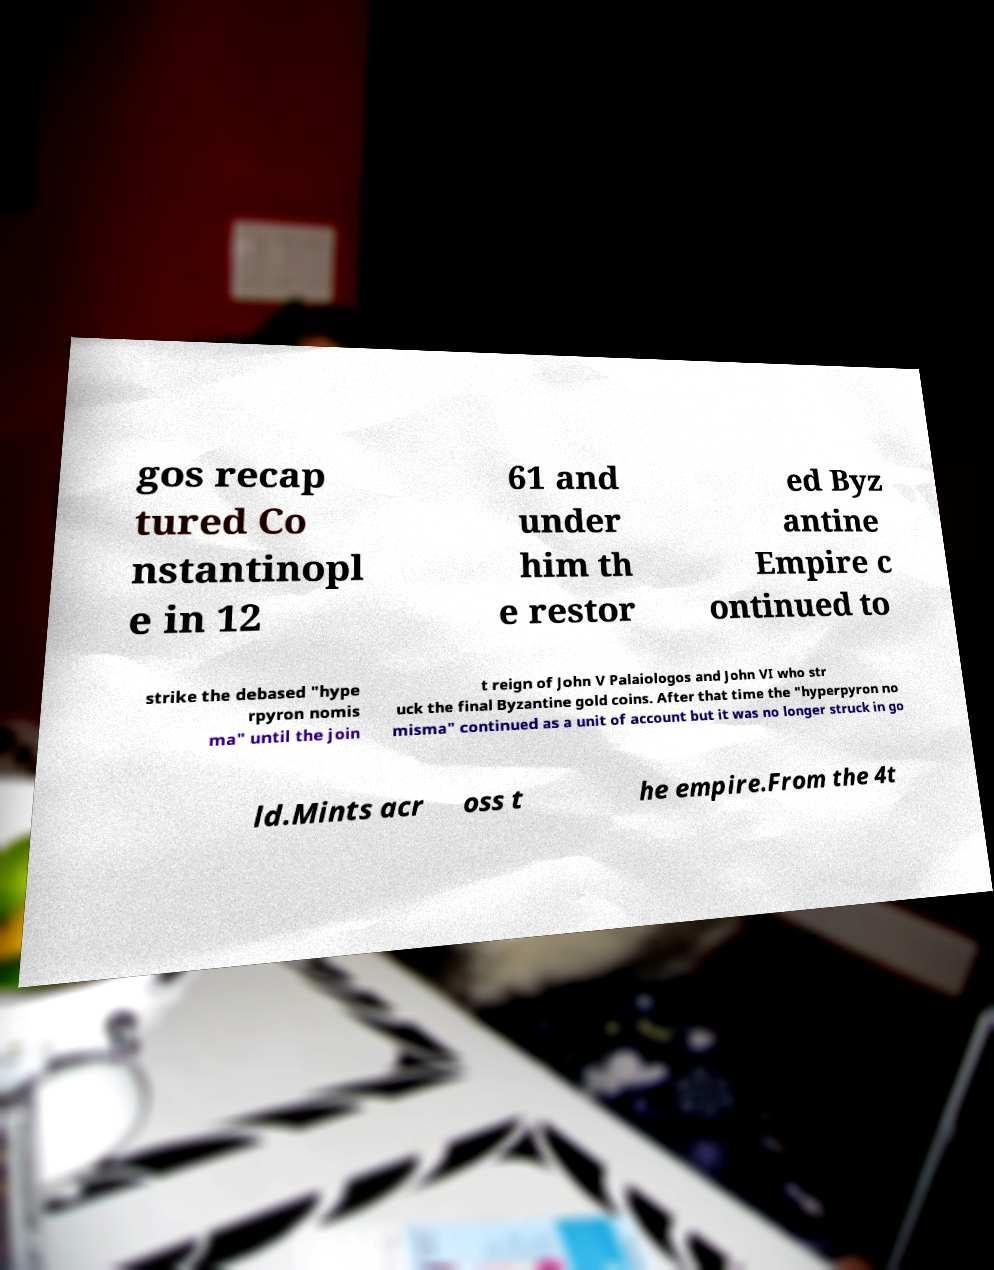Can you read and provide the text displayed in the image?This photo seems to have some interesting text. Can you extract and type it out for me? gos recap tured Co nstantinopl e in 12 61 and under him th e restor ed Byz antine Empire c ontinued to strike the debased "hype rpyron nomis ma" until the join t reign of John V Palaiologos and John VI who str uck the final Byzantine gold coins. After that time the "hyperpyron no misma" continued as a unit of account but it was no longer struck in go ld.Mints acr oss t he empire.From the 4t 